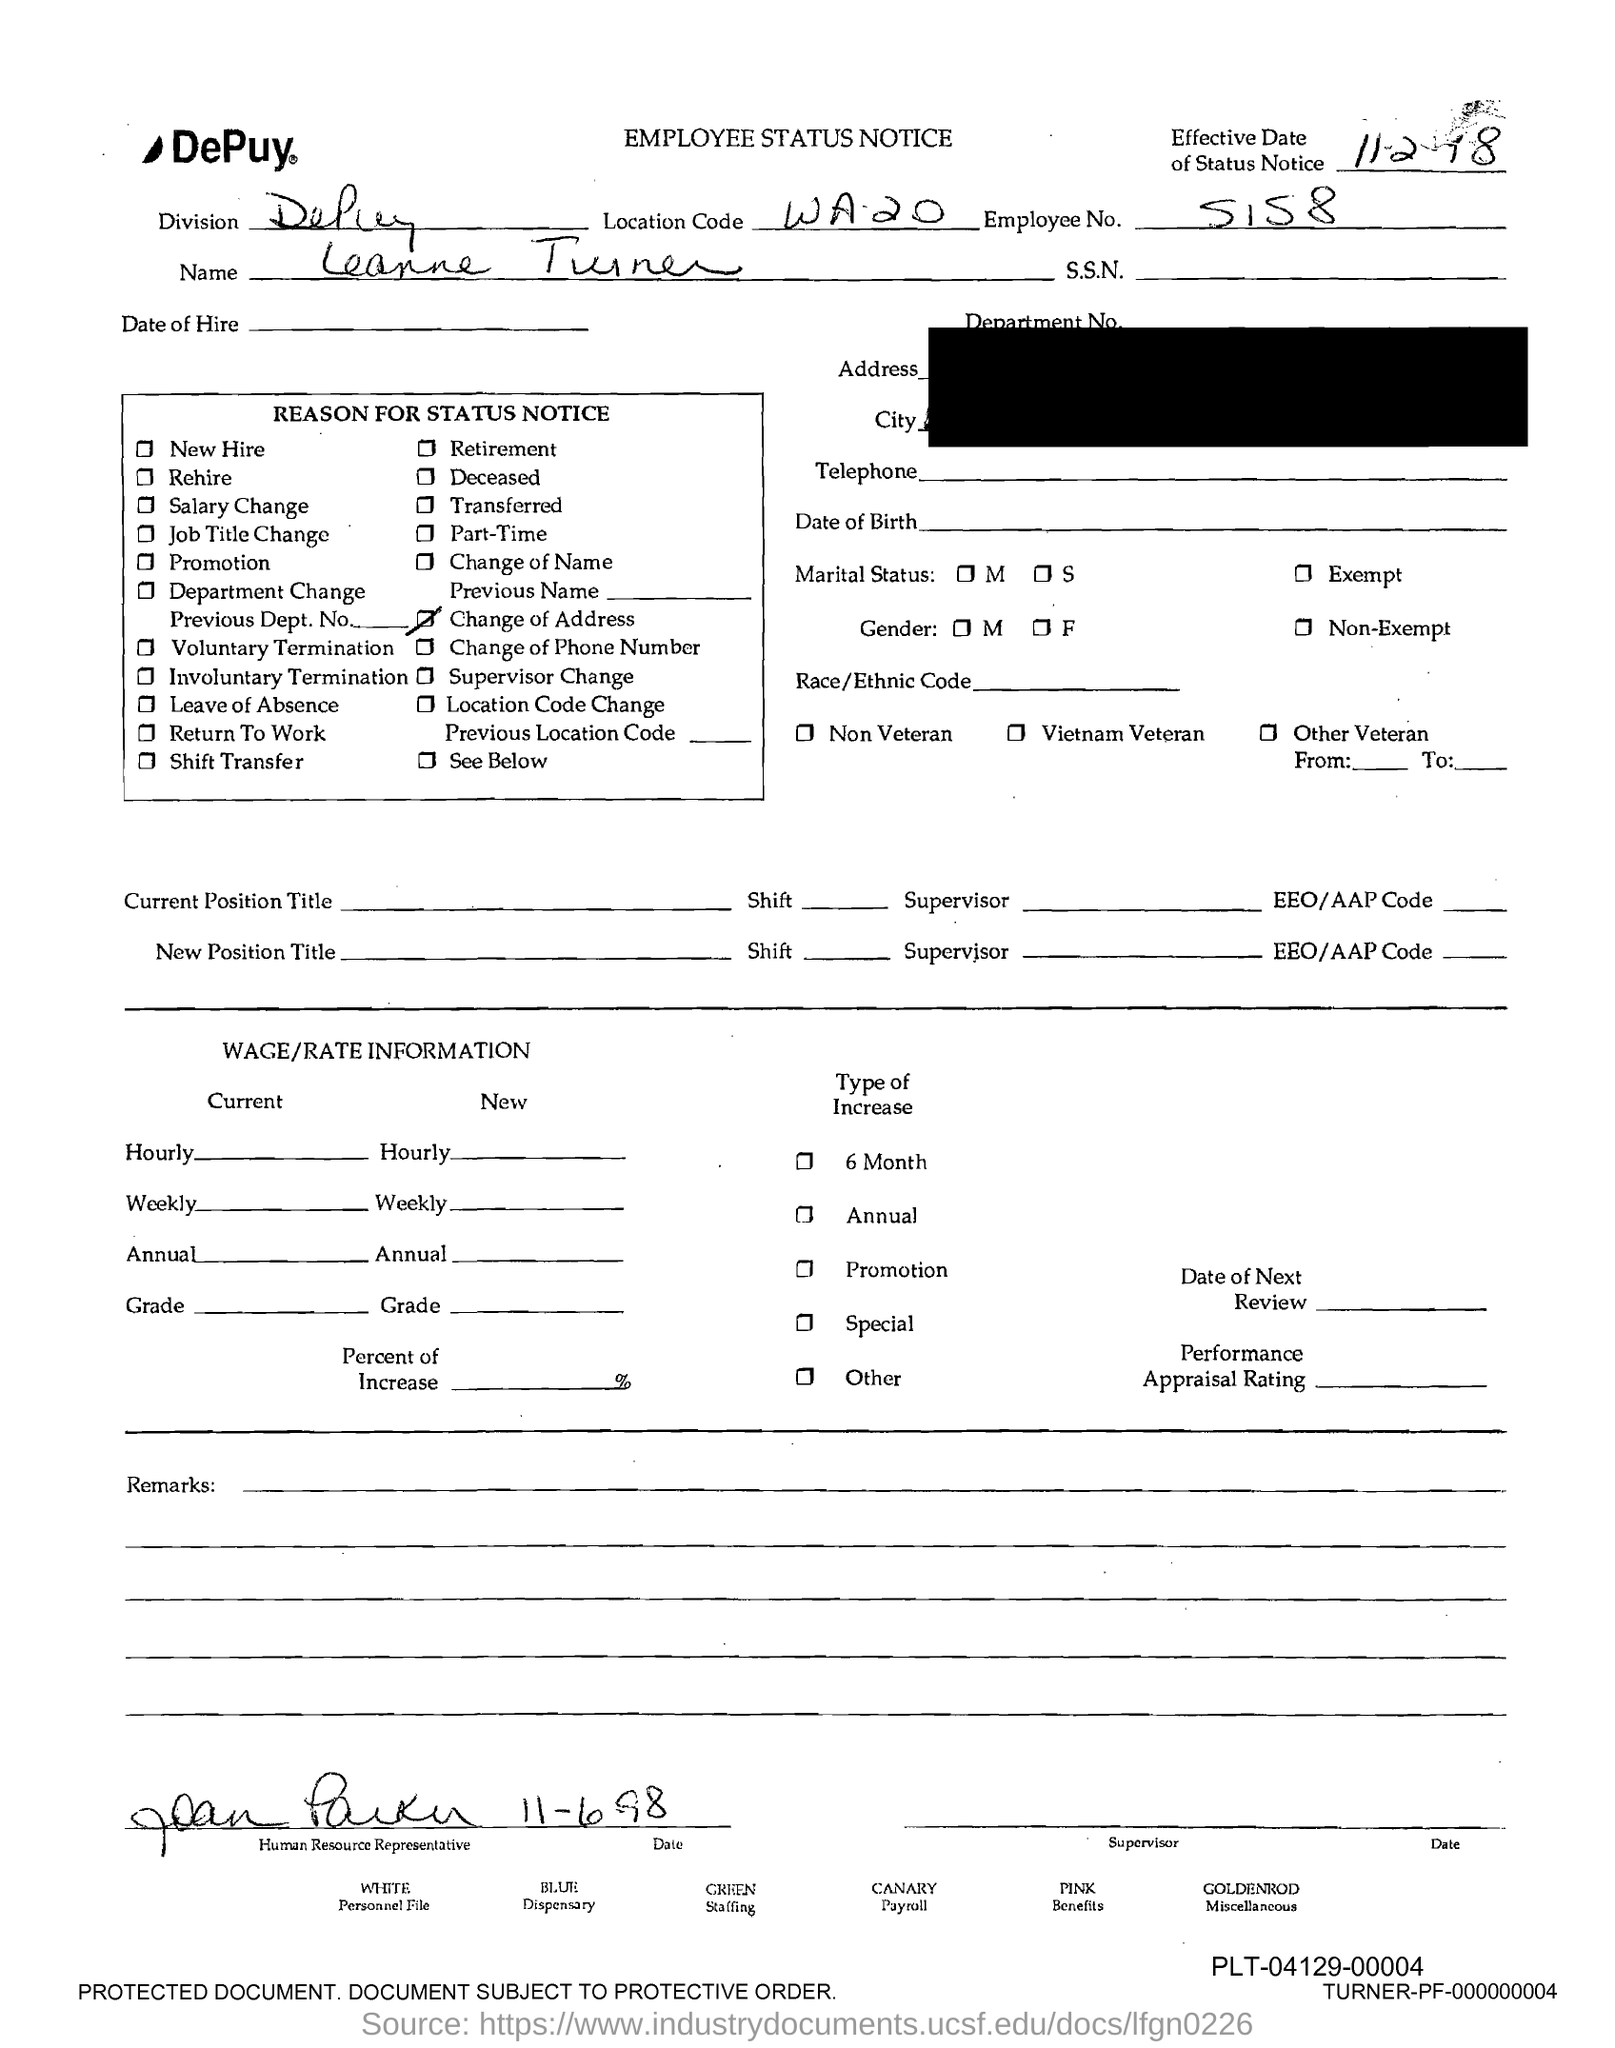Specify some key components in this picture. The employee number is 5158. The location code is WA.20. 